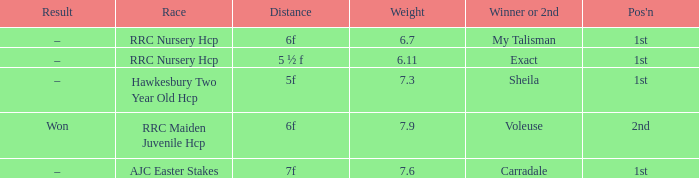What is the the name of the winner or 2nd  with a weight more than 7.3, and the result was –? Carradale. 